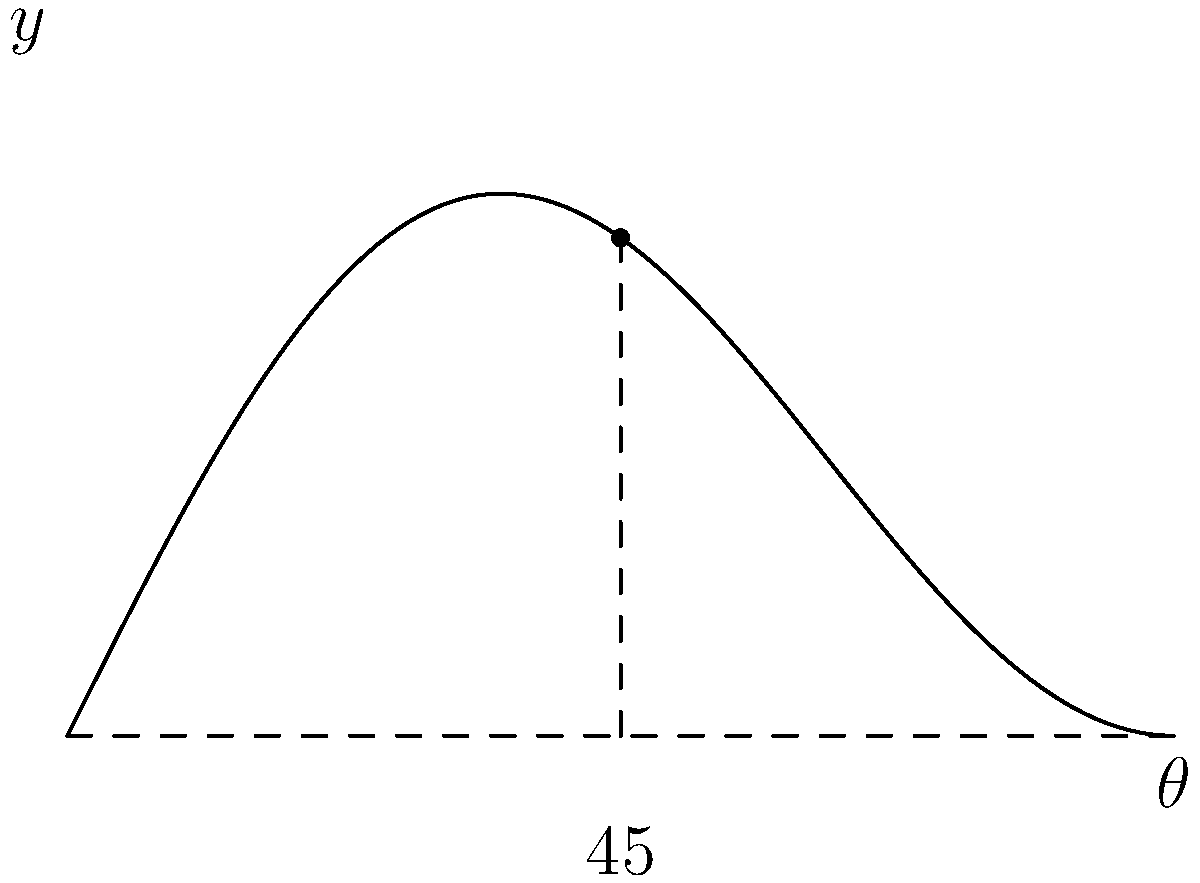The graph shows the relationship between the takeoff angle ($\theta$) and the distance achieved in a long jump. Based on the diagram, what is the optimal takeoff angle for maximizing the jump distance? To determine the optimal takeoff angle for a long jump, we need to analyze the given graph:

1. The x-axis represents the takeoff angle ($\theta$) from 0° to 90°.
2. The y-axis represents the relative jump distance.
3. The curve shows how the jump distance varies with the takeoff angle.
4. The highest point on the curve corresponds to the maximum jump distance.

Observing the graph:

1. The curve reaches its peak at approximately the midpoint of the x-axis.
2. This midpoint is labeled as 45°.
3. The vertical dashed line from this peak intersects the x-axis at 45°.

In physics, the optimal launch angle for projectile motion in a vacuum is 45°. However, in real-world conditions with air resistance, the optimal angle is slightly less than 45°. For simplicity in long jump competitions and training, 45° is often used as a target angle.

The graph confirms this theoretical knowledge, showing the maximum distance achieved at a 45° takeoff angle.
Answer: 45° 